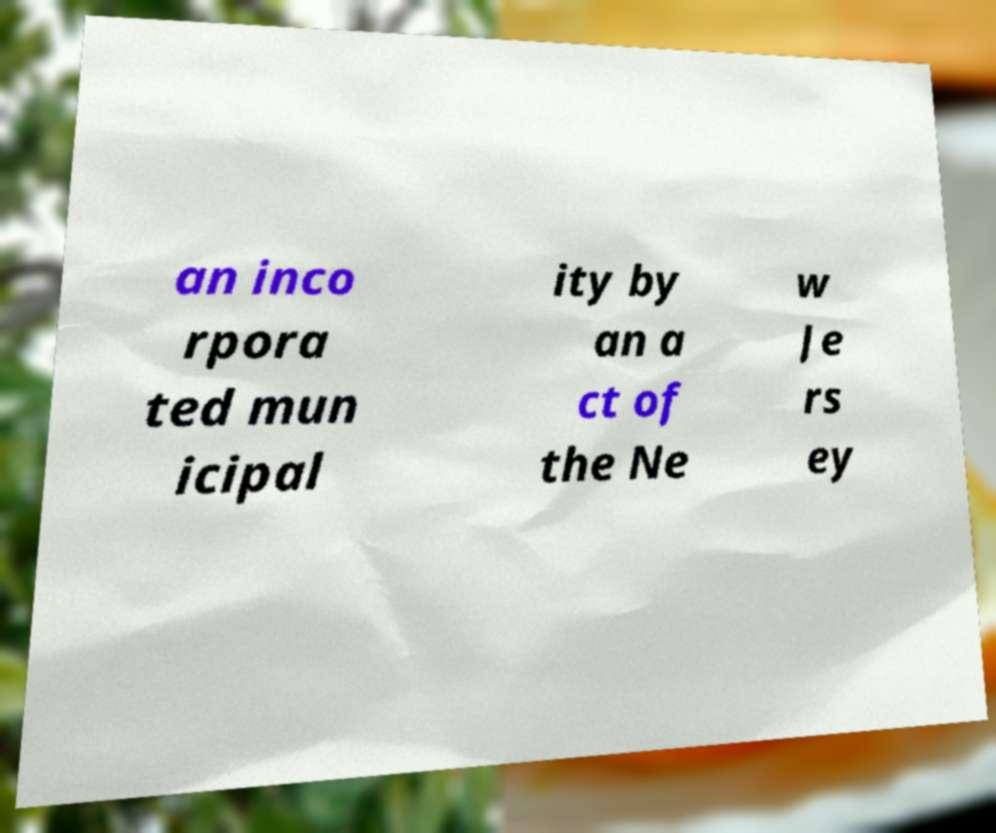Can you accurately transcribe the text from the provided image for me? an inco rpora ted mun icipal ity by an a ct of the Ne w Je rs ey 